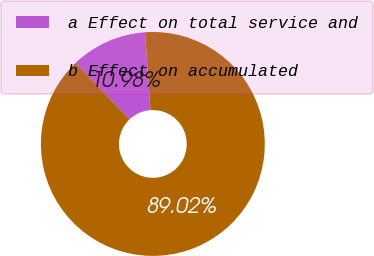Convert chart. <chart><loc_0><loc_0><loc_500><loc_500><pie_chart><fcel>a Effect on total service and<fcel>b Effect on accumulated<nl><fcel>10.98%<fcel>89.02%<nl></chart> 